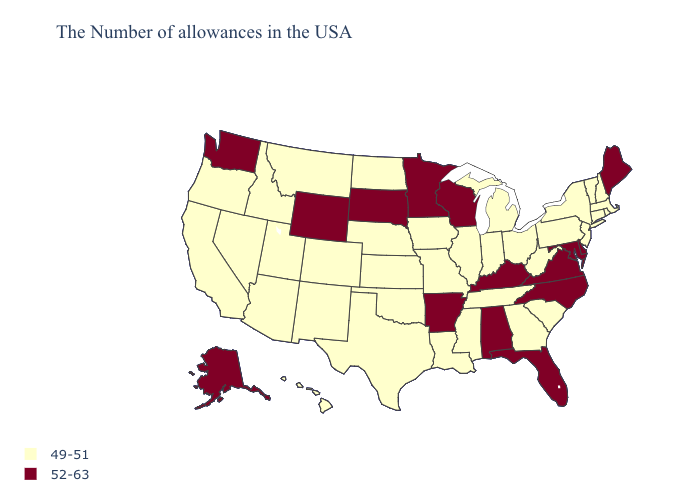Does Hawaii have a higher value than Wyoming?
Give a very brief answer. No. Does Washington have the highest value in the West?
Give a very brief answer. Yes. Does Pennsylvania have the lowest value in the USA?
Answer briefly. Yes. Does Wisconsin have the lowest value in the MidWest?
Give a very brief answer. No. Name the states that have a value in the range 49-51?
Quick response, please. Massachusetts, Rhode Island, New Hampshire, Vermont, Connecticut, New York, New Jersey, Pennsylvania, South Carolina, West Virginia, Ohio, Georgia, Michigan, Indiana, Tennessee, Illinois, Mississippi, Louisiana, Missouri, Iowa, Kansas, Nebraska, Oklahoma, Texas, North Dakota, Colorado, New Mexico, Utah, Montana, Arizona, Idaho, Nevada, California, Oregon, Hawaii. Is the legend a continuous bar?
Short answer required. No. Does the first symbol in the legend represent the smallest category?
Be succinct. Yes. Which states hav the highest value in the MidWest?
Quick response, please. Wisconsin, Minnesota, South Dakota. Name the states that have a value in the range 49-51?
Answer briefly. Massachusetts, Rhode Island, New Hampshire, Vermont, Connecticut, New York, New Jersey, Pennsylvania, South Carolina, West Virginia, Ohio, Georgia, Michigan, Indiana, Tennessee, Illinois, Mississippi, Louisiana, Missouri, Iowa, Kansas, Nebraska, Oklahoma, Texas, North Dakota, Colorado, New Mexico, Utah, Montana, Arizona, Idaho, Nevada, California, Oregon, Hawaii. What is the value of Rhode Island?
Be succinct. 49-51. Among the states that border Oregon , which have the highest value?
Short answer required. Washington. What is the highest value in states that border Kentucky?
Be succinct. 52-63. Does the first symbol in the legend represent the smallest category?
Answer briefly. Yes. What is the value of New Jersey?
Write a very short answer. 49-51. 